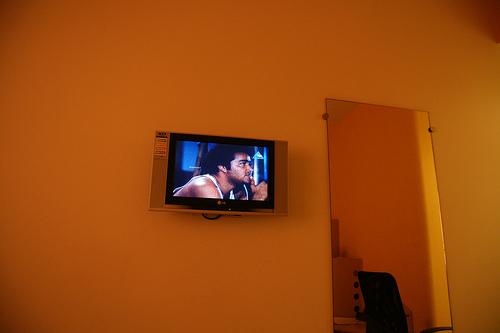What color is the wall?
Write a very short answer. Orange. What does it appear that the man on the television is looking at in the room?
Be succinct. Mirror. Is this room lit like a movie theater would be while watching a movie?
Short answer required. No. Where is the art?
Give a very brief answer. Wall. Is there a mirror in the room?
Be succinct. Yes. Is the TV turned on?
Concise answer only. Yes. How many prints are on the wall?
Short answer required. 0. How many TV screens are in the picture?
Answer briefly. 1. Is the TV right side up?
Give a very brief answer. Yes. Is the movie being shown an older film?
Quick response, please. Yes. Is there a piano on the stage?
Keep it brief. No. 